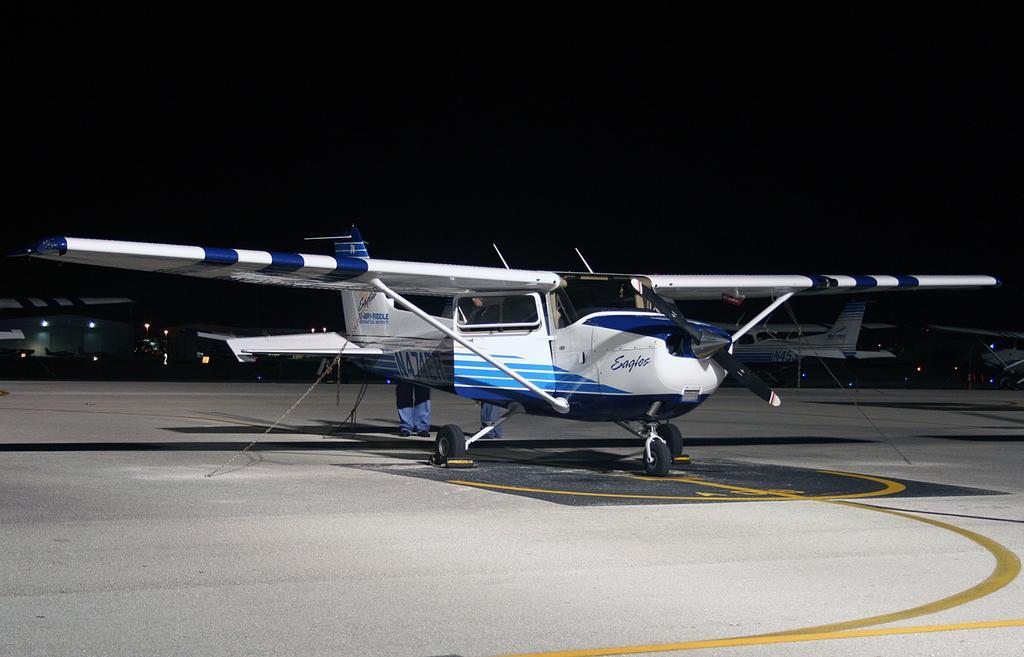Can you describe this image briefly? In the center of the image we can see one airplane, which is in blue and white color. And we can see one person standing. In the background we can see vehicles, airplanes, lights and a few other objects. 